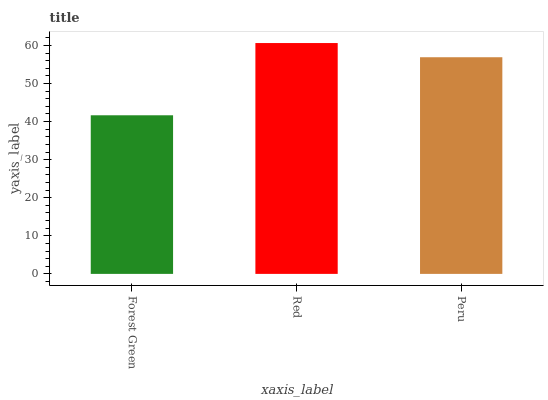Is Forest Green the minimum?
Answer yes or no. Yes. Is Red the maximum?
Answer yes or no. Yes. Is Peru the minimum?
Answer yes or no. No. Is Peru the maximum?
Answer yes or no. No. Is Red greater than Peru?
Answer yes or no. Yes. Is Peru less than Red?
Answer yes or no. Yes. Is Peru greater than Red?
Answer yes or no. No. Is Red less than Peru?
Answer yes or no. No. Is Peru the high median?
Answer yes or no. Yes. Is Peru the low median?
Answer yes or no. Yes. Is Red the high median?
Answer yes or no. No. Is Red the low median?
Answer yes or no. No. 